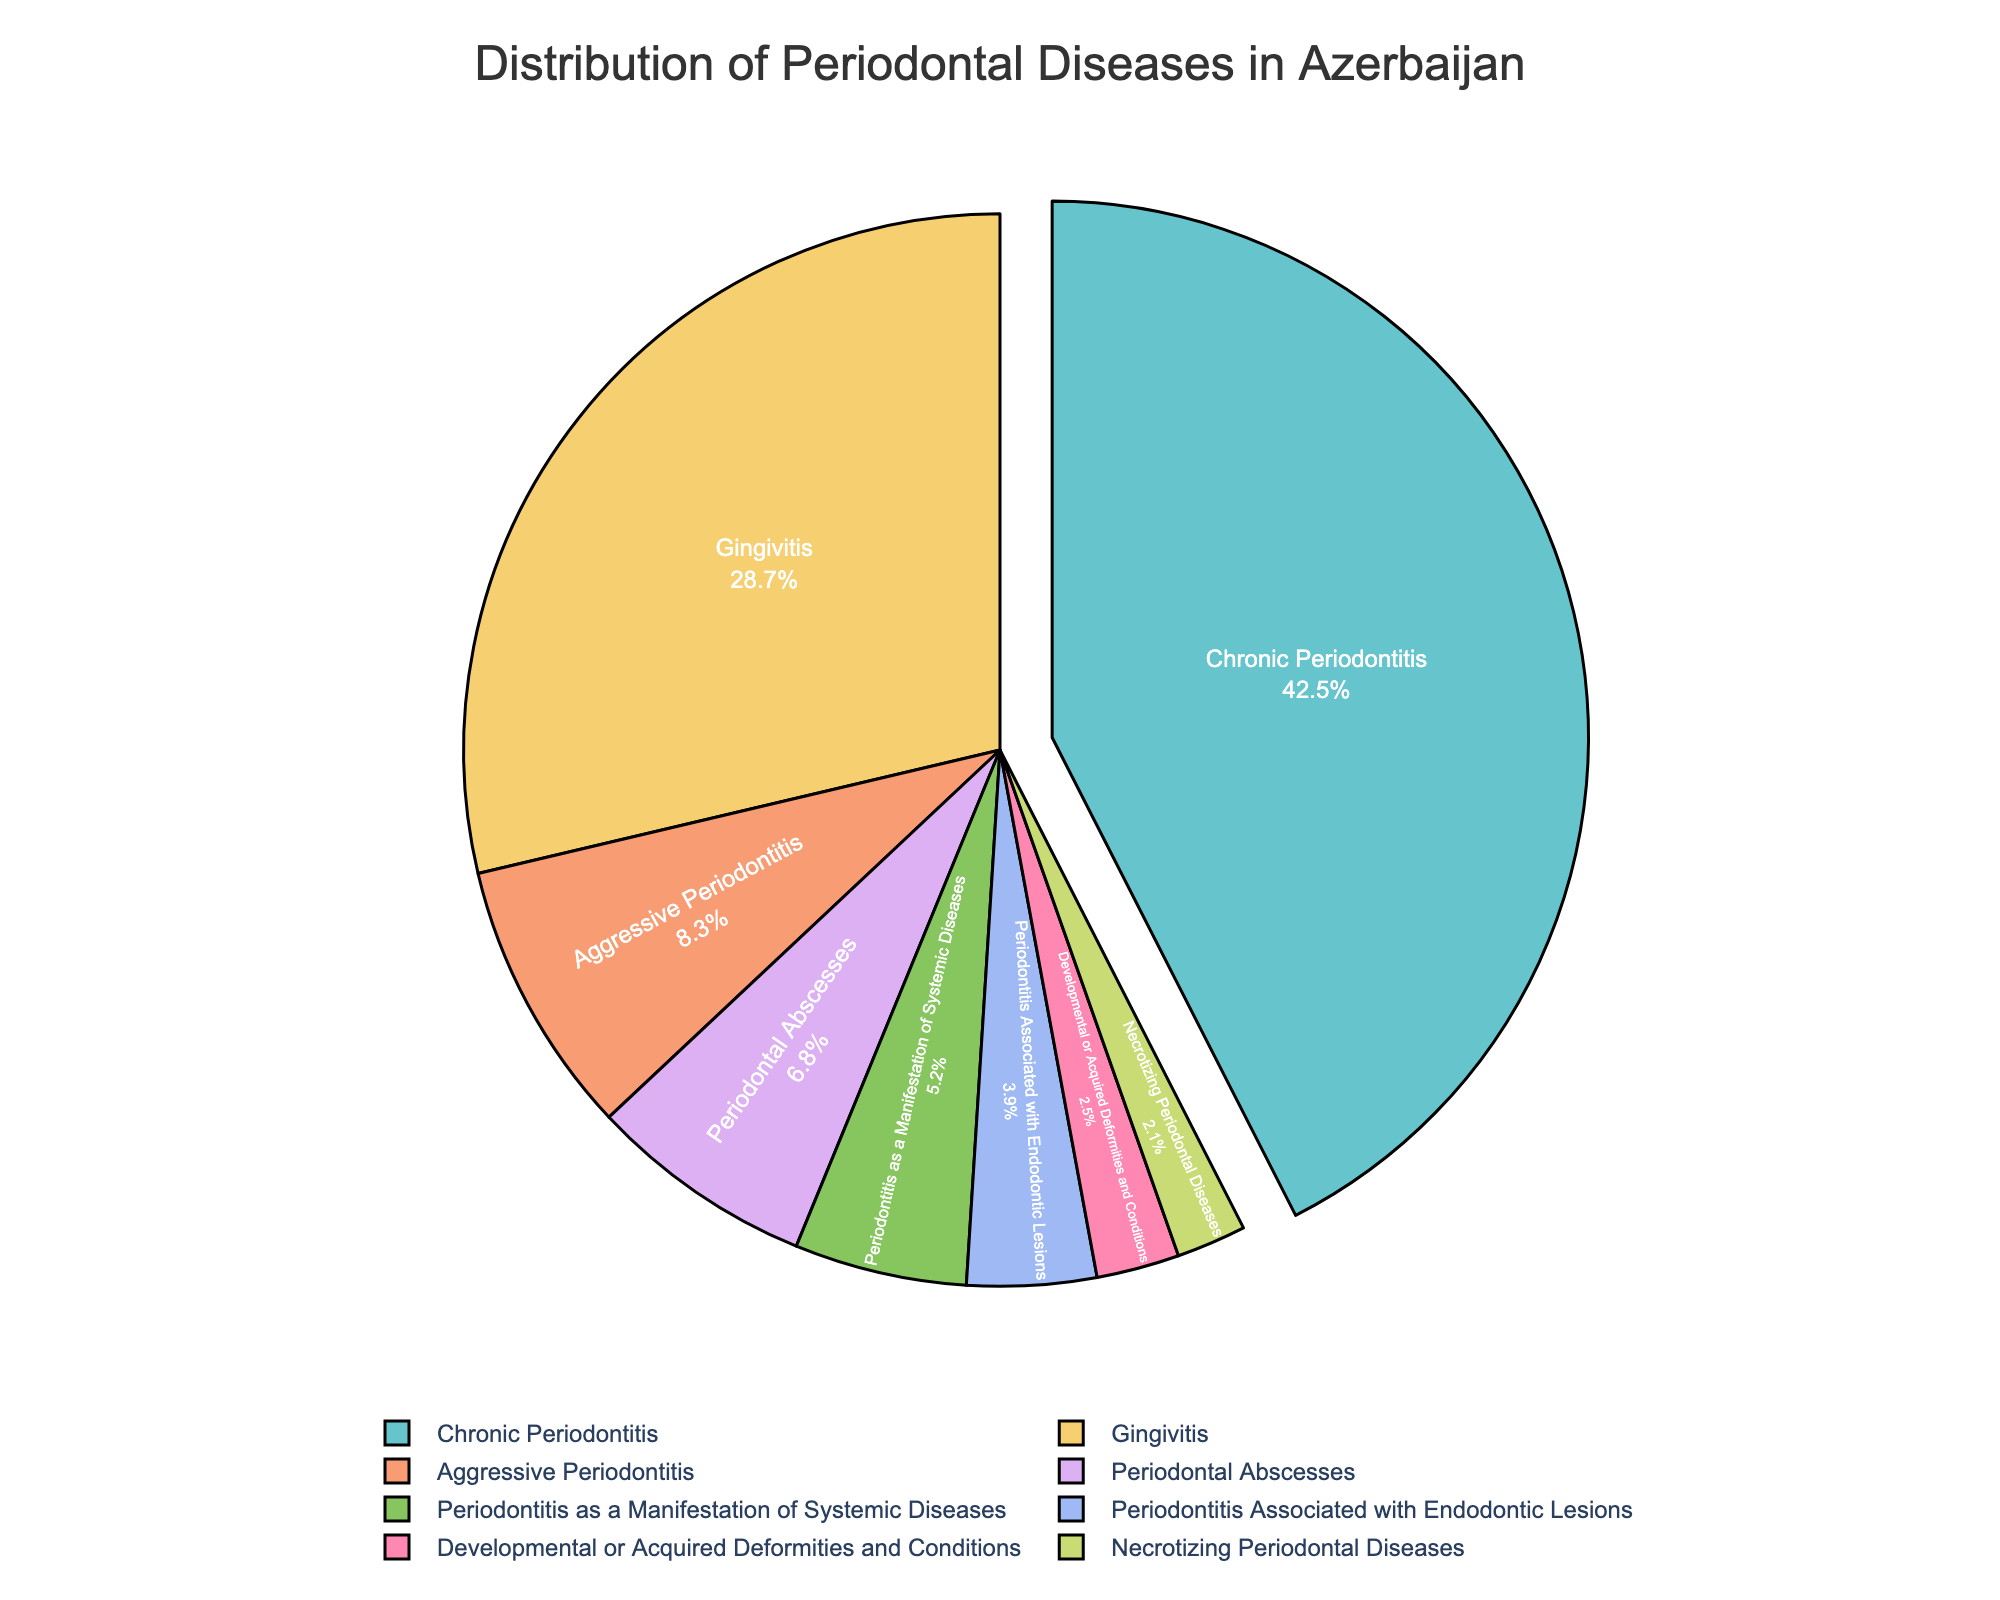Which type of periodontal disease has the highest percentage distribution? The chart shows various types of periodontal diseases and their percentage distributions. The highest percentage distribution is indicated by the largest segment.
Answer: Chronic Periodontitis Which two types of periodontal diseases together make up more than 50% of the total distribution? The chart shows the percentage distribution of each type of periodontal disease. By summing the two highest percentages: Chronic Periodontitis (42.5%) and Gingivitis (28.7%), we get 71.2%, which is more than 50%.
Answer: Chronic Periodontitis and Gingivitis What is the difference in percentage between Chronic Periodontitis and Aggressive Periodontitis? Subtract the percentage of Aggressive Periodontitis (8.3%) from Chronic Periodontitis (42.5%). 42.5% - 8.3% gives the difference.
Answer: 34.2% How many types of periodontal diseases have a percentage distribution less than 10%? By examining each type's percentage in the chart, we identify those less than 10%: Aggressive Periodontitis (8.3%), Periodontitis as a Manifestation of Systemic Diseases (5.2%), Necrotizing Periodontal Diseases (2.1%), Periodontal Abscesses (6.8%), Periodontitis Associated with Endodontic Lesions (3.9%), Developmental or Acquired Deformities and Conditions (2.5%). In total, there are 6 types.
Answer: 6 Which type of periodontal disease has the smallest percentage distribution, and what is its percentage? The chart shows various types and their percentage distributions. The smallest segment represents the smallest percentage.
Answer: Necrotizing Periodontal Diseases, 2.1% Compare the percentage distribution of Periodontal Abscesses and Periodontitis Associated with Endodontic Lesions. Which is higher and by how much? The chart shows the percentages for Periodontal Abscesses (6.8%) and Periodontitis Associated with Endodontic Lesions (3.9%). Subtract 3.9% from 6.8% to find the difference.
Answer: Periodontal Abscesses, higher by 2.9% What is the combined percentage of Developmental or Acquired Deformities and Conditions and Necrotizing Periodontal Diseases? Add the percentages of Developmental or Acquired Deformities and Conditions (2.5%) and Necrotizing Periodontal Diseases (2.1%). 2.5% + 2.1% gives the combined percentage.
Answer: 4.6% What's the average percentage distribution of Chronic Periodontitis, Gingivitis, and Aggressive Periodontitis? Add the percentages of Chronic Periodontitis (42.5%), Gingivitis (28.7%), and Aggressive Periodontitis (8.3%), then divide by 3 to get the average. (42.5 + 28.7 + 8.3) / 3 = 26.5%
Answer: 26.5% 